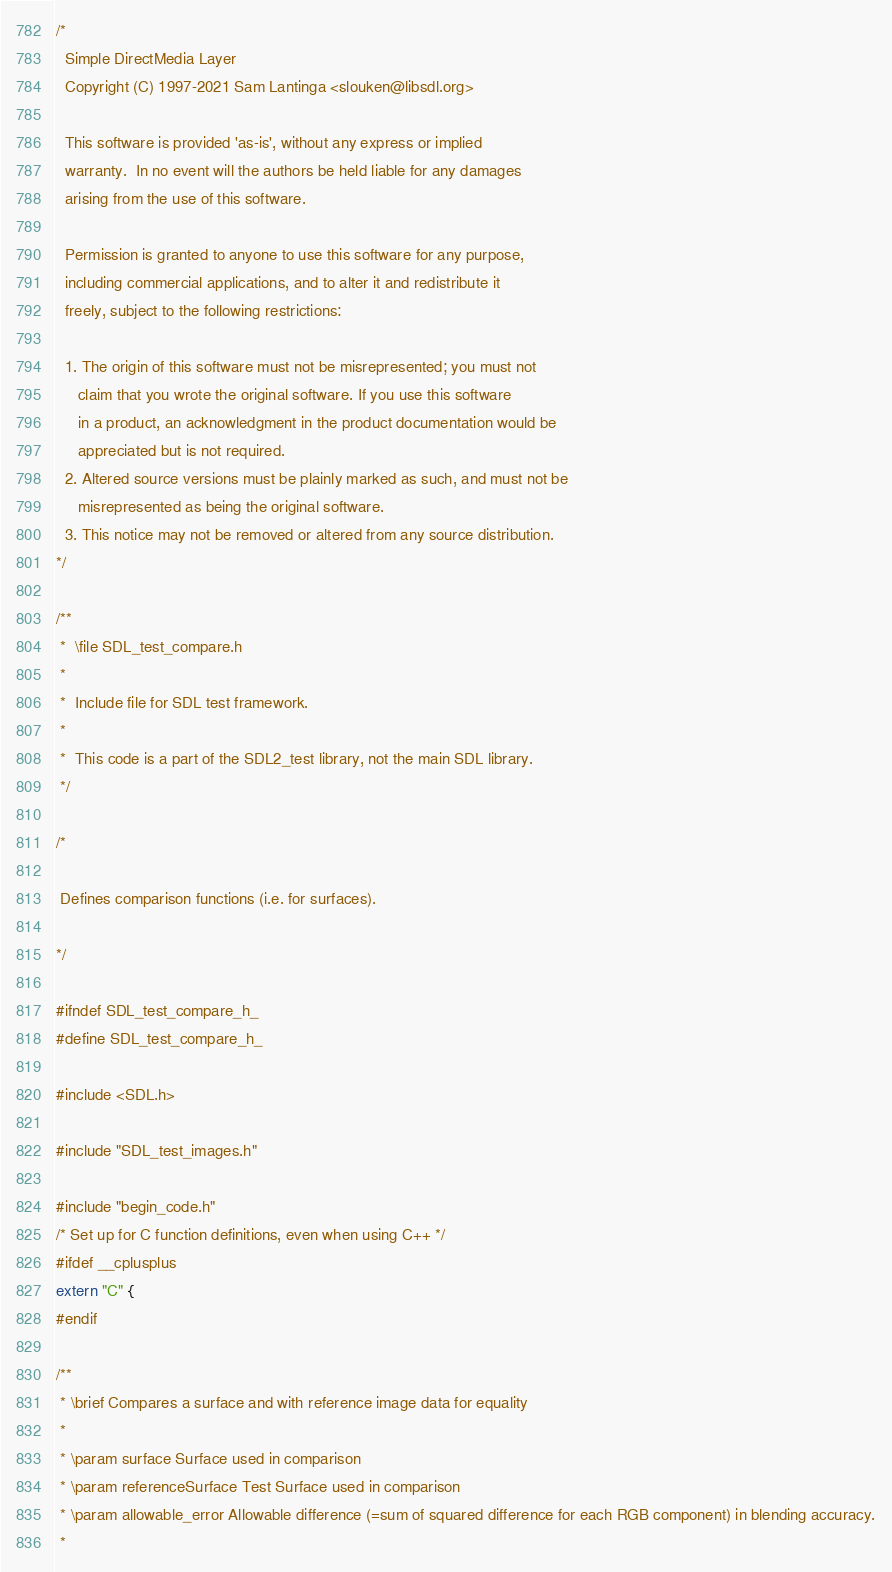<code> <loc_0><loc_0><loc_500><loc_500><_C_>/*
  Simple DirectMedia Layer
  Copyright (C) 1997-2021 Sam Lantinga <slouken@libsdl.org>

  This software is provided 'as-is', without any express or implied
  warranty.  In no event will the authors be held liable for any damages
  arising from the use of this software.

  Permission is granted to anyone to use this software for any purpose,
  including commercial applications, and to alter it and redistribute it
  freely, subject to the following restrictions:

  1. The origin of this software must not be misrepresented; you must not
     claim that you wrote the original software. If you use this software
     in a product, an acknowledgment in the product documentation would be
     appreciated but is not required.
  2. Altered source versions must be plainly marked as such, and must not be
     misrepresented as being the original software.
  3. This notice may not be removed or altered from any source distribution.
*/

/**
 *  \file SDL_test_compare.h
 *
 *  Include file for SDL test framework.
 *
 *  This code is a part of the SDL2_test library, not the main SDL library.
 */

/*

 Defines comparison functions (i.e. for surfaces).

*/

#ifndef SDL_test_compare_h_
#define SDL_test_compare_h_

#include <SDL.h>

#include "SDL_test_images.h"

#include "begin_code.h"
/* Set up for C function definitions, even when using C++ */
#ifdef __cplusplus
extern "C" {
#endif

/**
 * \brief Compares a surface and with reference image data for equality
 *
 * \param surface Surface used in comparison
 * \param referenceSurface Test Surface used in comparison
 * \param allowable_error Allowable difference (=sum of squared difference for each RGB component) in blending accuracy.
 *</code> 